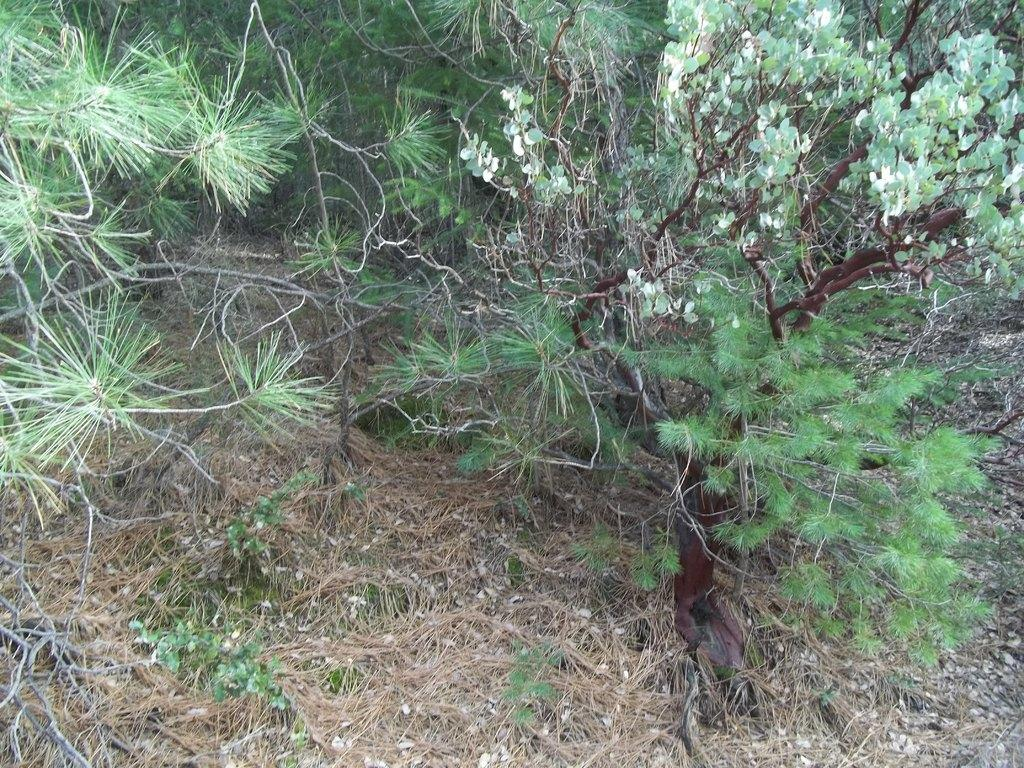What types of vegetation can be seen in the image? There are different types of trees in the image. What is present at the bottom of the image? There is grass at the bottom of the image. What parts of the trees are visible in the image? Tree branches are visible in the image. How does the earthquake affect the trees in the image? There is no earthquake present in the image, so its effects cannot be observed. 